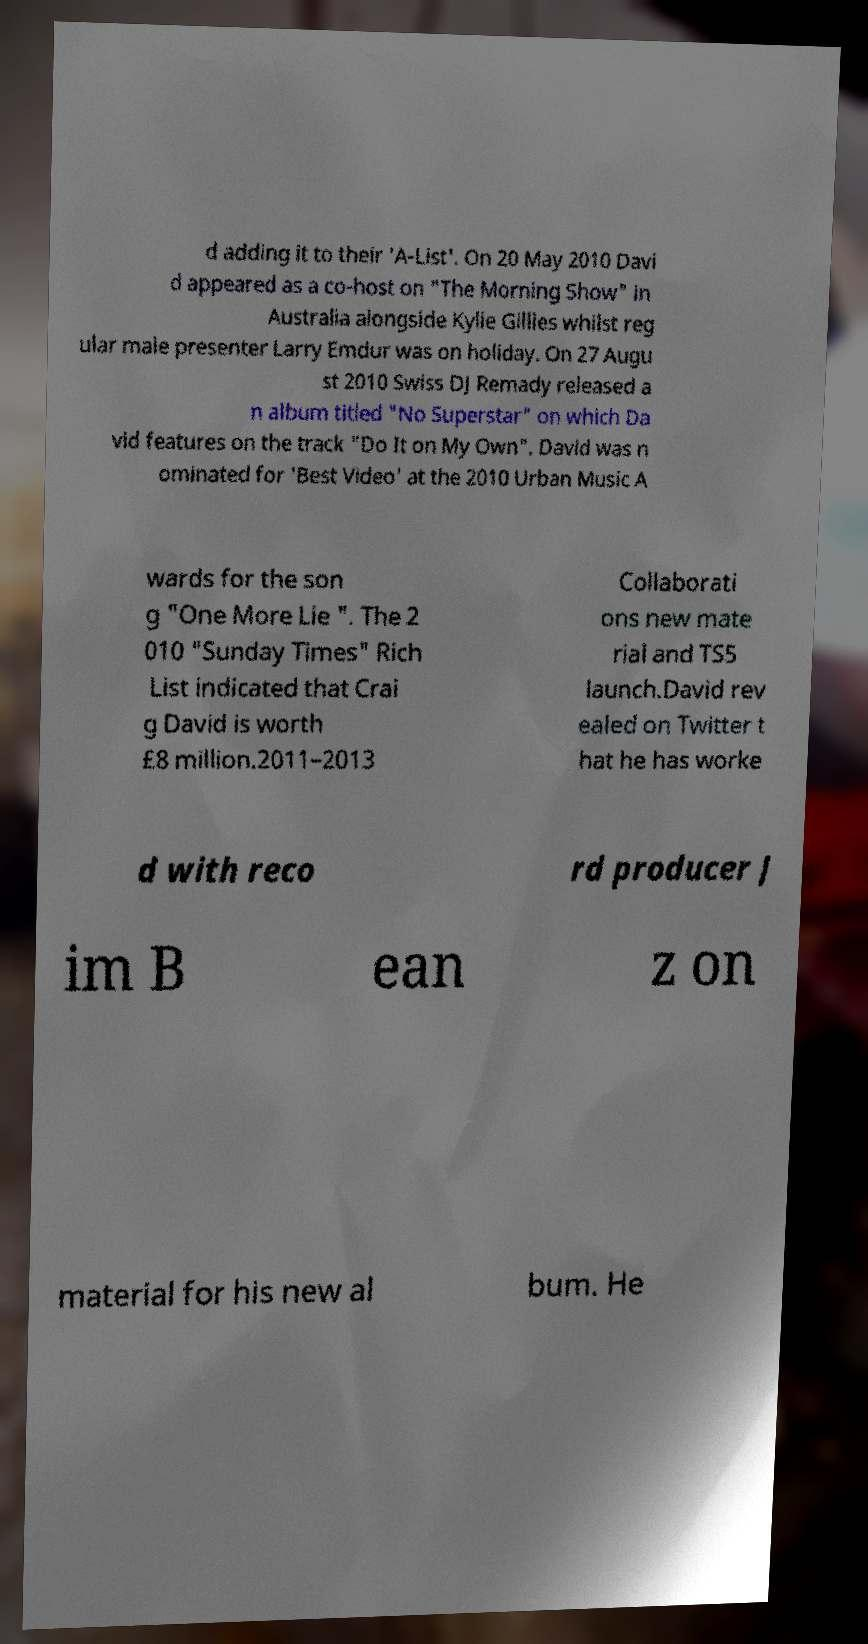What messages or text are displayed in this image? I need them in a readable, typed format. d adding it to their 'A-List'. On 20 May 2010 Davi d appeared as a co-host on "The Morning Show" in Australia alongside Kylie Gillies whilst reg ular male presenter Larry Emdur was on holiday. On 27 Augu st 2010 Swiss DJ Remady released a n album titled "No Superstar" on which Da vid features on the track "Do It on My Own". David was n ominated for 'Best Video' at the 2010 Urban Music A wards for the son g "One More Lie ". The 2 010 "Sunday Times" Rich List indicated that Crai g David is worth £8 million.2011–2013 Collaborati ons new mate rial and TS5 launch.David rev ealed on Twitter t hat he has worke d with reco rd producer J im B ean z on material for his new al bum. He 